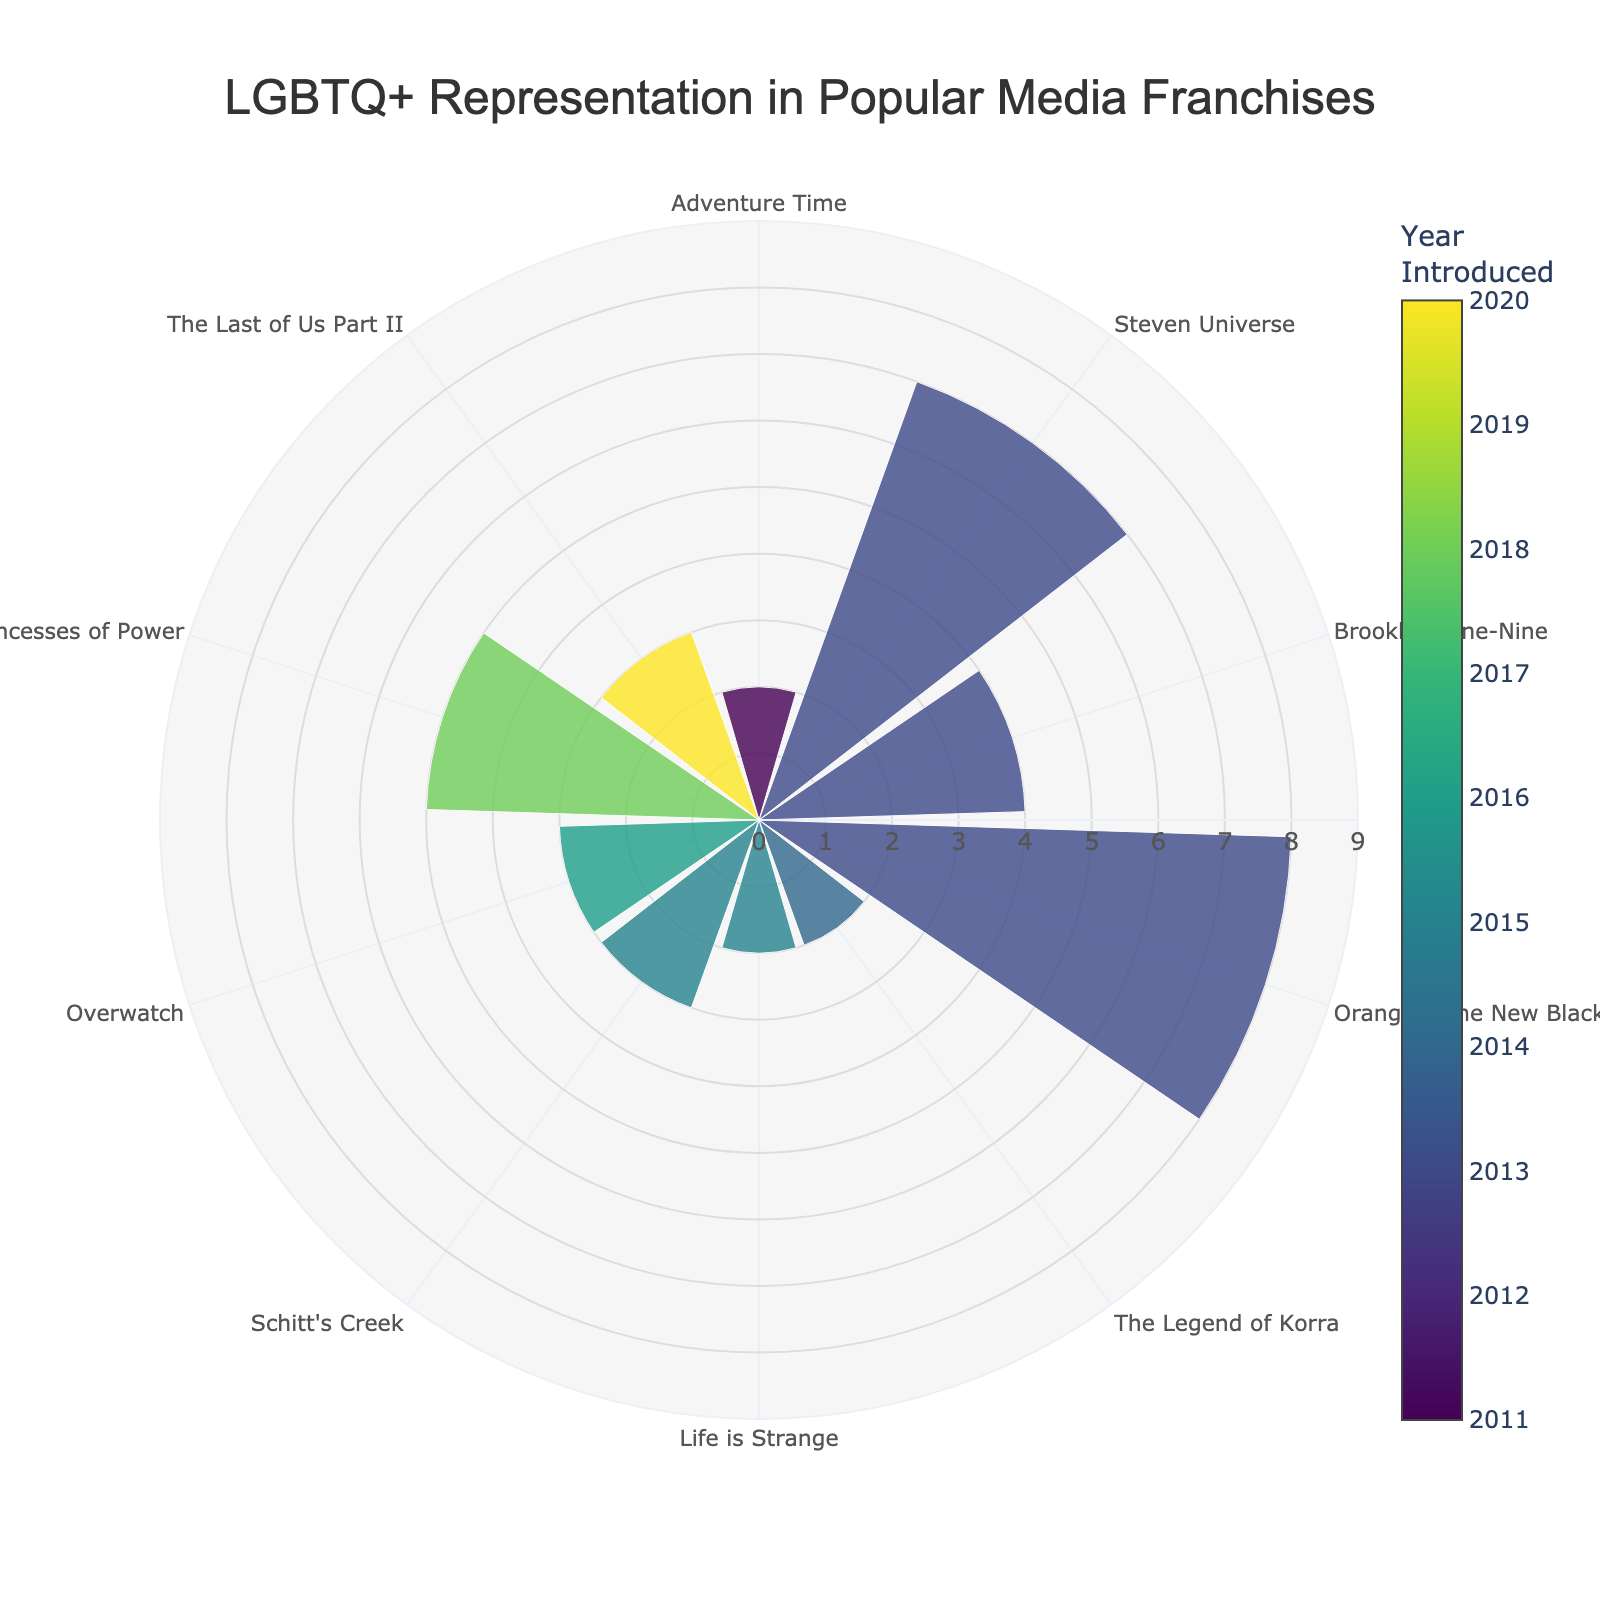What is the title of the polar area chart? The title is displayed at the top of the chart. It reads 'LGBTQ+ Representation in Popular Media Franchises'.
Answer: LGBTQ+ Representation in Popular Media Franchises Which franchise has the highest number of LGBTQ+ characters? By examining the radial length of the bars, 'Orange is the New Black' has the longest bar, indicating the highest number of LGBTQ+ characters with a value of 8.
Answer: Orange is the New Black How many LGBTQ+ characters were introduced in 2015? Look for the bars in the colors that correspond to the year 2015. 'Life is Strange' (2 characters) and 'Schitt's Creek' (3 characters) were introduced in 2015. Summing these give 5 characters.
Answer: 5 Which years have franchises with the same number of LGBTQ+ characters, and what is that number? Observing the radial lengths and their colors, 'The Legend of Korra' and 'Adventure Time' both introduced 2 characters each in 2014 and 2011 respectively.
Answer: 2014 and 2011, 2 characters Which franchise introduced LGBTQ+ characters in 2016 and how many? The color of the bar corresponding to the year 2016 points to the 'Overwatch' franchise with 3 LGBTQ+ characters.
Answer: Overwatch, 3 characters What is the median number of LGBTQ+ characters in the represented franchises? Organize the number of LGBTQ+ characters in ascending order: 2, 2, 2, 3, 3, 3, 4, 5, 7, 8. The median of these 10 values, situated between the 5th and 6th values, is (3 + 3)/2.
Answer: 3 Which two franchises have the same number of LGBTQ+ characters and in which years? Using both the radial lengths and the years, 'The Legend of Korra' (2014) and 'Life is Strange' (2015) both have 2 characters each.
Answer: The Legend of Korra (2014) and Life is Strange (2015), 2 characters Which franchise has the longest bar and how many characters does it represent? The bar extending the farthest from the center represents 'Orange is the New Black' with 8 characters.
Answer: Orange is the New Black, 8 characters Does 'She-Ra and the Princesses of Power' have more or fewer LGBTQ+ characters than 'Brooklyn Nine-Nine'? The bar lengths for 'She-Ra and the Princesses of Power' is 5, while 'Brooklyn Nine-Nine' is 4. Thus, 'She-Ra and the Princesses of Power' has more characters.
Answer: More What is the total number of LGBTQ+ characters across all franchises? Add up the number of LGBTQ+ characters from each franchise: 2 + 3 + 2 + 7 + 3 + 2 + 5 + 4 + 8 + 3, which totals 39.
Answer: 39 